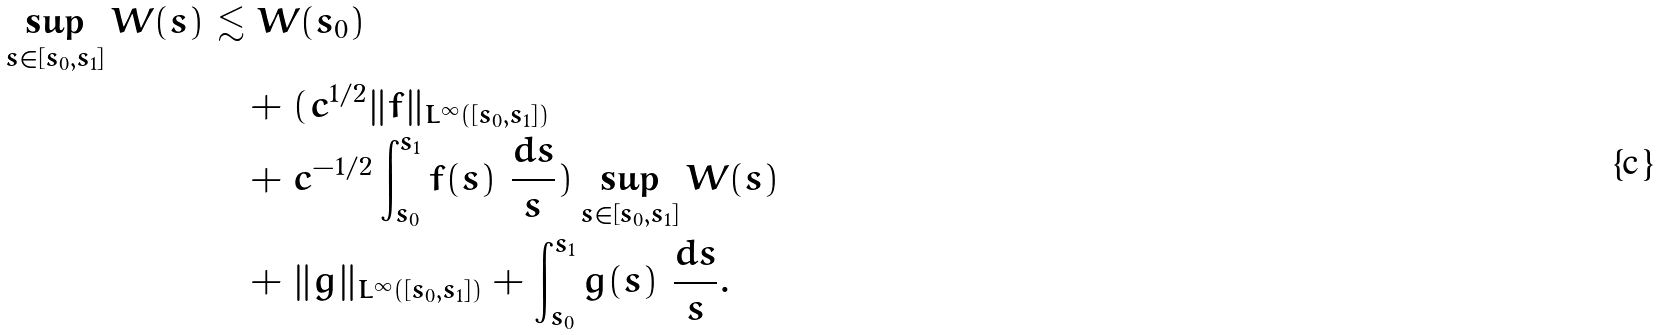Convert formula to latex. <formula><loc_0><loc_0><loc_500><loc_500>\sup _ { s \in [ s _ { 0 } , s _ { 1 } ] } W ( s ) & \lesssim W ( s _ { 0 } ) \\ & \quad + ( c ^ { 1 / 2 } \| f \| _ { L ^ { \infty } ( [ s _ { 0 } , s _ { 1 } ] ) } \\ & \quad + c ^ { - 1 / 2 } \int _ { s _ { 0 } } ^ { s _ { 1 } } f ( s ) \ \frac { d s } { s } ) \sup _ { s \in [ s _ { 0 } , s _ { 1 } ] } W ( s ) \\ & \quad + \| g \| _ { L ^ { \infty } ( [ s _ { 0 } , s _ { 1 } ] ) } + \int _ { s _ { 0 } } ^ { s _ { 1 } } g ( s ) \ \frac { d s } { s } .</formula> 